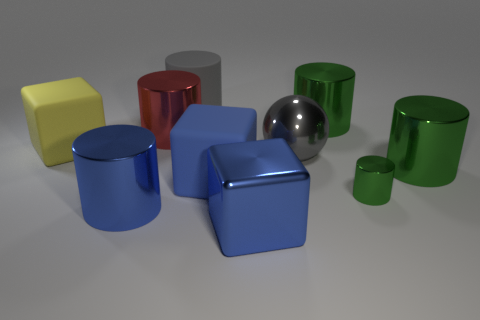The red metallic thing that is the same size as the gray metal object is what shape? cylinder 